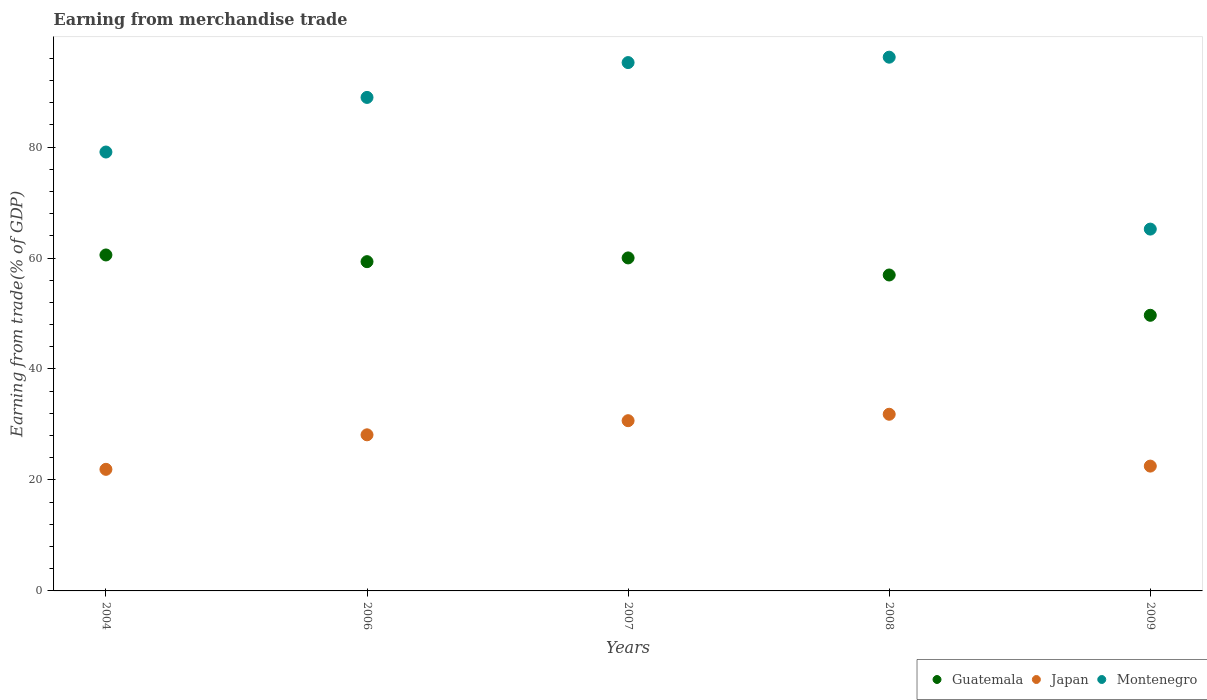What is the earnings from trade in Japan in 2009?
Offer a terse response. 22.5. Across all years, what is the maximum earnings from trade in Montenegro?
Your answer should be very brief. 96.2. Across all years, what is the minimum earnings from trade in Montenegro?
Your answer should be compact. 65.21. In which year was the earnings from trade in Guatemala minimum?
Your answer should be compact. 2009. What is the total earnings from trade in Japan in the graph?
Your answer should be compact. 135.06. What is the difference between the earnings from trade in Montenegro in 2008 and that in 2009?
Provide a succinct answer. 30.98. What is the difference between the earnings from trade in Montenegro in 2004 and the earnings from trade in Japan in 2007?
Provide a short and direct response. 48.42. What is the average earnings from trade in Japan per year?
Your answer should be very brief. 27.01. In the year 2008, what is the difference between the earnings from trade in Montenegro and earnings from trade in Japan?
Keep it short and to the point. 64.36. In how many years, is the earnings from trade in Montenegro greater than 68 %?
Keep it short and to the point. 4. What is the ratio of the earnings from trade in Guatemala in 2006 to that in 2007?
Provide a succinct answer. 0.99. Is the earnings from trade in Guatemala in 2007 less than that in 2009?
Provide a succinct answer. No. Is the difference between the earnings from trade in Montenegro in 2004 and 2006 greater than the difference between the earnings from trade in Japan in 2004 and 2006?
Provide a short and direct response. No. What is the difference between the highest and the second highest earnings from trade in Montenegro?
Provide a succinct answer. 0.97. What is the difference between the highest and the lowest earnings from trade in Guatemala?
Your answer should be compact. 10.87. Is it the case that in every year, the sum of the earnings from trade in Montenegro and earnings from trade in Guatemala  is greater than the earnings from trade in Japan?
Give a very brief answer. Yes. Is the earnings from trade in Japan strictly greater than the earnings from trade in Guatemala over the years?
Give a very brief answer. No. Is the earnings from trade in Montenegro strictly less than the earnings from trade in Guatemala over the years?
Your answer should be very brief. No. Are the values on the major ticks of Y-axis written in scientific E-notation?
Your answer should be very brief. No. Does the graph contain grids?
Your response must be concise. No. How are the legend labels stacked?
Your answer should be compact. Horizontal. What is the title of the graph?
Provide a succinct answer. Earning from merchandise trade. What is the label or title of the Y-axis?
Your answer should be compact. Earning from trade(% of GDP). What is the Earning from trade(% of GDP) in Guatemala in 2004?
Your answer should be very brief. 60.55. What is the Earning from trade(% of GDP) of Japan in 2004?
Your response must be concise. 21.91. What is the Earning from trade(% of GDP) of Montenegro in 2004?
Your response must be concise. 79.1. What is the Earning from trade(% of GDP) of Guatemala in 2006?
Keep it short and to the point. 59.34. What is the Earning from trade(% of GDP) of Japan in 2006?
Ensure brevity in your answer.  28.14. What is the Earning from trade(% of GDP) in Montenegro in 2006?
Offer a very short reply. 88.94. What is the Earning from trade(% of GDP) of Guatemala in 2007?
Provide a succinct answer. 60.02. What is the Earning from trade(% of GDP) in Japan in 2007?
Offer a terse response. 30.68. What is the Earning from trade(% of GDP) in Montenegro in 2007?
Give a very brief answer. 95.22. What is the Earning from trade(% of GDP) of Guatemala in 2008?
Make the answer very short. 56.94. What is the Earning from trade(% of GDP) of Japan in 2008?
Make the answer very short. 31.84. What is the Earning from trade(% of GDP) of Montenegro in 2008?
Give a very brief answer. 96.2. What is the Earning from trade(% of GDP) in Guatemala in 2009?
Provide a succinct answer. 49.68. What is the Earning from trade(% of GDP) in Japan in 2009?
Provide a short and direct response. 22.5. What is the Earning from trade(% of GDP) in Montenegro in 2009?
Give a very brief answer. 65.21. Across all years, what is the maximum Earning from trade(% of GDP) in Guatemala?
Offer a terse response. 60.55. Across all years, what is the maximum Earning from trade(% of GDP) of Japan?
Your answer should be compact. 31.84. Across all years, what is the maximum Earning from trade(% of GDP) of Montenegro?
Offer a very short reply. 96.2. Across all years, what is the minimum Earning from trade(% of GDP) of Guatemala?
Your answer should be very brief. 49.68. Across all years, what is the minimum Earning from trade(% of GDP) in Japan?
Offer a terse response. 21.91. Across all years, what is the minimum Earning from trade(% of GDP) of Montenegro?
Your answer should be compact. 65.21. What is the total Earning from trade(% of GDP) of Guatemala in the graph?
Provide a succinct answer. 286.52. What is the total Earning from trade(% of GDP) in Japan in the graph?
Your response must be concise. 135.06. What is the total Earning from trade(% of GDP) in Montenegro in the graph?
Your response must be concise. 424.68. What is the difference between the Earning from trade(% of GDP) of Guatemala in 2004 and that in 2006?
Provide a short and direct response. 1.21. What is the difference between the Earning from trade(% of GDP) in Japan in 2004 and that in 2006?
Your answer should be very brief. -6.22. What is the difference between the Earning from trade(% of GDP) of Montenegro in 2004 and that in 2006?
Keep it short and to the point. -9.84. What is the difference between the Earning from trade(% of GDP) of Guatemala in 2004 and that in 2007?
Your answer should be compact. 0.53. What is the difference between the Earning from trade(% of GDP) of Japan in 2004 and that in 2007?
Provide a short and direct response. -8.77. What is the difference between the Earning from trade(% of GDP) of Montenegro in 2004 and that in 2007?
Give a very brief answer. -16.12. What is the difference between the Earning from trade(% of GDP) of Guatemala in 2004 and that in 2008?
Your answer should be compact. 3.61. What is the difference between the Earning from trade(% of GDP) in Japan in 2004 and that in 2008?
Make the answer very short. -9.93. What is the difference between the Earning from trade(% of GDP) of Montenegro in 2004 and that in 2008?
Keep it short and to the point. -17.09. What is the difference between the Earning from trade(% of GDP) of Guatemala in 2004 and that in 2009?
Your answer should be compact. 10.87. What is the difference between the Earning from trade(% of GDP) of Japan in 2004 and that in 2009?
Your answer should be compact. -0.58. What is the difference between the Earning from trade(% of GDP) in Montenegro in 2004 and that in 2009?
Your response must be concise. 13.89. What is the difference between the Earning from trade(% of GDP) in Guatemala in 2006 and that in 2007?
Your answer should be compact. -0.68. What is the difference between the Earning from trade(% of GDP) in Japan in 2006 and that in 2007?
Make the answer very short. -2.55. What is the difference between the Earning from trade(% of GDP) in Montenegro in 2006 and that in 2007?
Keep it short and to the point. -6.28. What is the difference between the Earning from trade(% of GDP) of Guatemala in 2006 and that in 2008?
Your answer should be compact. 2.4. What is the difference between the Earning from trade(% of GDP) of Japan in 2006 and that in 2008?
Your answer should be compact. -3.7. What is the difference between the Earning from trade(% of GDP) in Montenegro in 2006 and that in 2008?
Your answer should be compact. -7.25. What is the difference between the Earning from trade(% of GDP) in Guatemala in 2006 and that in 2009?
Give a very brief answer. 9.66. What is the difference between the Earning from trade(% of GDP) in Japan in 2006 and that in 2009?
Your answer should be very brief. 5.64. What is the difference between the Earning from trade(% of GDP) in Montenegro in 2006 and that in 2009?
Your answer should be compact. 23.73. What is the difference between the Earning from trade(% of GDP) of Guatemala in 2007 and that in 2008?
Provide a short and direct response. 3.08. What is the difference between the Earning from trade(% of GDP) of Japan in 2007 and that in 2008?
Provide a short and direct response. -1.16. What is the difference between the Earning from trade(% of GDP) in Montenegro in 2007 and that in 2008?
Offer a very short reply. -0.97. What is the difference between the Earning from trade(% of GDP) in Guatemala in 2007 and that in 2009?
Your answer should be very brief. 10.34. What is the difference between the Earning from trade(% of GDP) in Japan in 2007 and that in 2009?
Your response must be concise. 8.19. What is the difference between the Earning from trade(% of GDP) of Montenegro in 2007 and that in 2009?
Offer a very short reply. 30.01. What is the difference between the Earning from trade(% of GDP) of Guatemala in 2008 and that in 2009?
Your answer should be very brief. 7.26. What is the difference between the Earning from trade(% of GDP) in Japan in 2008 and that in 2009?
Offer a very short reply. 9.34. What is the difference between the Earning from trade(% of GDP) in Montenegro in 2008 and that in 2009?
Your response must be concise. 30.98. What is the difference between the Earning from trade(% of GDP) in Guatemala in 2004 and the Earning from trade(% of GDP) in Japan in 2006?
Provide a short and direct response. 32.41. What is the difference between the Earning from trade(% of GDP) in Guatemala in 2004 and the Earning from trade(% of GDP) in Montenegro in 2006?
Provide a short and direct response. -28.39. What is the difference between the Earning from trade(% of GDP) in Japan in 2004 and the Earning from trade(% of GDP) in Montenegro in 2006?
Your answer should be compact. -67.03. What is the difference between the Earning from trade(% of GDP) in Guatemala in 2004 and the Earning from trade(% of GDP) in Japan in 2007?
Offer a terse response. 29.87. What is the difference between the Earning from trade(% of GDP) in Guatemala in 2004 and the Earning from trade(% of GDP) in Montenegro in 2007?
Offer a very short reply. -34.67. What is the difference between the Earning from trade(% of GDP) of Japan in 2004 and the Earning from trade(% of GDP) of Montenegro in 2007?
Keep it short and to the point. -73.31. What is the difference between the Earning from trade(% of GDP) in Guatemala in 2004 and the Earning from trade(% of GDP) in Japan in 2008?
Give a very brief answer. 28.71. What is the difference between the Earning from trade(% of GDP) in Guatemala in 2004 and the Earning from trade(% of GDP) in Montenegro in 2008?
Provide a short and direct response. -35.65. What is the difference between the Earning from trade(% of GDP) in Japan in 2004 and the Earning from trade(% of GDP) in Montenegro in 2008?
Your answer should be very brief. -74.28. What is the difference between the Earning from trade(% of GDP) in Guatemala in 2004 and the Earning from trade(% of GDP) in Japan in 2009?
Provide a short and direct response. 38.05. What is the difference between the Earning from trade(% of GDP) in Guatemala in 2004 and the Earning from trade(% of GDP) in Montenegro in 2009?
Ensure brevity in your answer.  -4.66. What is the difference between the Earning from trade(% of GDP) in Japan in 2004 and the Earning from trade(% of GDP) in Montenegro in 2009?
Offer a terse response. -43.3. What is the difference between the Earning from trade(% of GDP) of Guatemala in 2006 and the Earning from trade(% of GDP) of Japan in 2007?
Give a very brief answer. 28.66. What is the difference between the Earning from trade(% of GDP) in Guatemala in 2006 and the Earning from trade(% of GDP) in Montenegro in 2007?
Your answer should be compact. -35.88. What is the difference between the Earning from trade(% of GDP) of Japan in 2006 and the Earning from trade(% of GDP) of Montenegro in 2007?
Provide a short and direct response. -67.09. What is the difference between the Earning from trade(% of GDP) of Guatemala in 2006 and the Earning from trade(% of GDP) of Japan in 2008?
Your answer should be very brief. 27.5. What is the difference between the Earning from trade(% of GDP) in Guatemala in 2006 and the Earning from trade(% of GDP) in Montenegro in 2008?
Provide a short and direct response. -36.85. What is the difference between the Earning from trade(% of GDP) of Japan in 2006 and the Earning from trade(% of GDP) of Montenegro in 2008?
Offer a very short reply. -68.06. What is the difference between the Earning from trade(% of GDP) in Guatemala in 2006 and the Earning from trade(% of GDP) in Japan in 2009?
Offer a terse response. 36.85. What is the difference between the Earning from trade(% of GDP) of Guatemala in 2006 and the Earning from trade(% of GDP) of Montenegro in 2009?
Keep it short and to the point. -5.87. What is the difference between the Earning from trade(% of GDP) in Japan in 2006 and the Earning from trade(% of GDP) in Montenegro in 2009?
Keep it short and to the point. -37.08. What is the difference between the Earning from trade(% of GDP) of Guatemala in 2007 and the Earning from trade(% of GDP) of Japan in 2008?
Offer a very short reply. 28.18. What is the difference between the Earning from trade(% of GDP) of Guatemala in 2007 and the Earning from trade(% of GDP) of Montenegro in 2008?
Offer a terse response. -36.18. What is the difference between the Earning from trade(% of GDP) of Japan in 2007 and the Earning from trade(% of GDP) of Montenegro in 2008?
Make the answer very short. -65.51. What is the difference between the Earning from trade(% of GDP) of Guatemala in 2007 and the Earning from trade(% of GDP) of Japan in 2009?
Your response must be concise. 37.52. What is the difference between the Earning from trade(% of GDP) of Guatemala in 2007 and the Earning from trade(% of GDP) of Montenegro in 2009?
Offer a very short reply. -5.2. What is the difference between the Earning from trade(% of GDP) in Japan in 2007 and the Earning from trade(% of GDP) in Montenegro in 2009?
Ensure brevity in your answer.  -34.53. What is the difference between the Earning from trade(% of GDP) of Guatemala in 2008 and the Earning from trade(% of GDP) of Japan in 2009?
Your response must be concise. 34.44. What is the difference between the Earning from trade(% of GDP) of Guatemala in 2008 and the Earning from trade(% of GDP) of Montenegro in 2009?
Ensure brevity in your answer.  -8.27. What is the difference between the Earning from trade(% of GDP) of Japan in 2008 and the Earning from trade(% of GDP) of Montenegro in 2009?
Your answer should be very brief. -33.37. What is the average Earning from trade(% of GDP) of Guatemala per year?
Keep it short and to the point. 57.3. What is the average Earning from trade(% of GDP) of Japan per year?
Keep it short and to the point. 27.01. What is the average Earning from trade(% of GDP) of Montenegro per year?
Your response must be concise. 84.94. In the year 2004, what is the difference between the Earning from trade(% of GDP) in Guatemala and Earning from trade(% of GDP) in Japan?
Keep it short and to the point. 38.64. In the year 2004, what is the difference between the Earning from trade(% of GDP) in Guatemala and Earning from trade(% of GDP) in Montenegro?
Make the answer very short. -18.55. In the year 2004, what is the difference between the Earning from trade(% of GDP) of Japan and Earning from trade(% of GDP) of Montenegro?
Keep it short and to the point. -57.19. In the year 2006, what is the difference between the Earning from trade(% of GDP) of Guatemala and Earning from trade(% of GDP) of Japan?
Ensure brevity in your answer.  31.21. In the year 2006, what is the difference between the Earning from trade(% of GDP) of Guatemala and Earning from trade(% of GDP) of Montenegro?
Keep it short and to the point. -29.6. In the year 2006, what is the difference between the Earning from trade(% of GDP) in Japan and Earning from trade(% of GDP) in Montenegro?
Your answer should be compact. -60.81. In the year 2007, what is the difference between the Earning from trade(% of GDP) of Guatemala and Earning from trade(% of GDP) of Japan?
Ensure brevity in your answer.  29.34. In the year 2007, what is the difference between the Earning from trade(% of GDP) of Guatemala and Earning from trade(% of GDP) of Montenegro?
Your answer should be very brief. -35.21. In the year 2007, what is the difference between the Earning from trade(% of GDP) in Japan and Earning from trade(% of GDP) in Montenegro?
Give a very brief answer. -64.54. In the year 2008, what is the difference between the Earning from trade(% of GDP) in Guatemala and Earning from trade(% of GDP) in Japan?
Offer a terse response. 25.1. In the year 2008, what is the difference between the Earning from trade(% of GDP) of Guatemala and Earning from trade(% of GDP) of Montenegro?
Provide a short and direct response. -39.26. In the year 2008, what is the difference between the Earning from trade(% of GDP) in Japan and Earning from trade(% of GDP) in Montenegro?
Give a very brief answer. -64.36. In the year 2009, what is the difference between the Earning from trade(% of GDP) in Guatemala and Earning from trade(% of GDP) in Japan?
Provide a succinct answer. 27.18. In the year 2009, what is the difference between the Earning from trade(% of GDP) of Guatemala and Earning from trade(% of GDP) of Montenegro?
Ensure brevity in your answer.  -15.53. In the year 2009, what is the difference between the Earning from trade(% of GDP) of Japan and Earning from trade(% of GDP) of Montenegro?
Provide a short and direct response. -42.72. What is the ratio of the Earning from trade(% of GDP) of Guatemala in 2004 to that in 2006?
Your answer should be compact. 1.02. What is the ratio of the Earning from trade(% of GDP) of Japan in 2004 to that in 2006?
Make the answer very short. 0.78. What is the ratio of the Earning from trade(% of GDP) of Montenegro in 2004 to that in 2006?
Provide a short and direct response. 0.89. What is the ratio of the Earning from trade(% of GDP) of Guatemala in 2004 to that in 2007?
Your answer should be very brief. 1.01. What is the ratio of the Earning from trade(% of GDP) of Japan in 2004 to that in 2007?
Keep it short and to the point. 0.71. What is the ratio of the Earning from trade(% of GDP) in Montenegro in 2004 to that in 2007?
Your answer should be compact. 0.83. What is the ratio of the Earning from trade(% of GDP) of Guatemala in 2004 to that in 2008?
Provide a short and direct response. 1.06. What is the ratio of the Earning from trade(% of GDP) of Japan in 2004 to that in 2008?
Your response must be concise. 0.69. What is the ratio of the Earning from trade(% of GDP) of Montenegro in 2004 to that in 2008?
Provide a succinct answer. 0.82. What is the ratio of the Earning from trade(% of GDP) of Guatemala in 2004 to that in 2009?
Make the answer very short. 1.22. What is the ratio of the Earning from trade(% of GDP) in Japan in 2004 to that in 2009?
Your response must be concise. 0.97. What is the ratio of the Earning from trade(% of GDP) in Montenegro in 2004 to that in 2009?
Keep it short and to the point. 1.21. What is the ratio of the Earning from trade(% of GDP) of Guatemala in 2006 to that in 2007?
Keep it short and to the point. 0.99. What is the ratio of the Earning from trade(% of GDP) of Japan in 2006 to that in 2007?
Make the answer very short. 0.92. What is the ratio of the Earning from trade(% of GDP) of Montenegro in 2006 to that in 2007?
Keep it short and to the point. 0.93. What is the ratio of the Earning from trade(% of GDP) of Guatemala in 2006 to that in 2008?
Provide a succinct answer. 1.04. What is the ratio of the Earning from trade(% of GDP) in Japan in 2006 to that in 2008?
Give a very brief answer. 0.88. What is the ratio of the Earning from trade(% of GDP) in Montenegro in 2006 to that in 2008?
Give a very brief answer. 0.92. What is the ratio of the Earning from trade(% of GDP) in Guatemala in 2006 to that in 2009?
Your answer should be compact. 1.19. What is the ratio of the Earning from trade(% of GDP) of Japan in 2006 to that in 2009?
Your response must be concise. 1.25. What is the ratio of the Earning from trade(% of GDP) in Montenegro in 2006 to that in 2009?
Your response must be concise. 1.36. What is the ratio of the Earning from trade(% of GDP) of Guatemala in 2007 to that in 2008?
Offer a very short reply. 1.05. What is the ratio of the Earning from trade(% of GDP) of Japan in 2007 to that in 2008?
Make the answer very short. 0.96. What is the ratio of the Earning from trade(% of GDP) of Guatemala in 2007 to that in 2009?
Your answer should be very brief. 1.21. What is the ratio of the Earning from trade(% of GDP) in Japan in 2007 to that in 2009?
Offer a terse response. 1.36. What is the ratio of the Earning from trade(% of GDP) of Montenegro in 2007 to that in 2009?
Provide a succinct answer. 1.46. What is the ratio of the Earning from trade(% of GDP) of Guatemala in 2008 to that in 2009?
Provide a short and direct response. 1.15. What is the ratio of the Earning from trade(% of GDP) in Japan in 2008 to that in 2009?
Your answer should be compact. 1.42. What is the ratio of the Earning from trade(% of GDP) in Montenegro in 2008 to that in 2009?
Keep it short and to the point. 1.48. What is the difference between the highest and the second highest Earning from trade(% of GDP) of Guatemala?
Provide a short and direct response. 0.53. What is the difference between the highest and the second highest Earning from trade(% of GDP) of Japan?
Ensure brevity in your answer.  1.16. What is the difference between the highest and the second highest Earning from trade(% of GDP) in Montenegro?
Ensure brevity in your answer.  0.97. What is the difference between the highest and the lowest Earning from trade(% of GDP) of Guatemala?
Your answer should be very brief. 10.87. What is the difference between the highest and the lowest Earning from trade(% of GDP) of Japan?
Offer a very short reply. 9.93. What is the difference between the highest and the lowest Earning from trade(% of GDP) in Montenegro?
Ensure brevity in your answer.  30.98. 